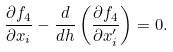<formula> <loc_0><loc_0><loc_500><loc_500>\frac { \partial f _ { 4 } } { \partial x _ { i } } - \frac { d } { d h } \left ( \frac { \partial f _ { 4 } } { \partial x _ { i } ^ { \prime } } \right ) = 0 .</formula> 